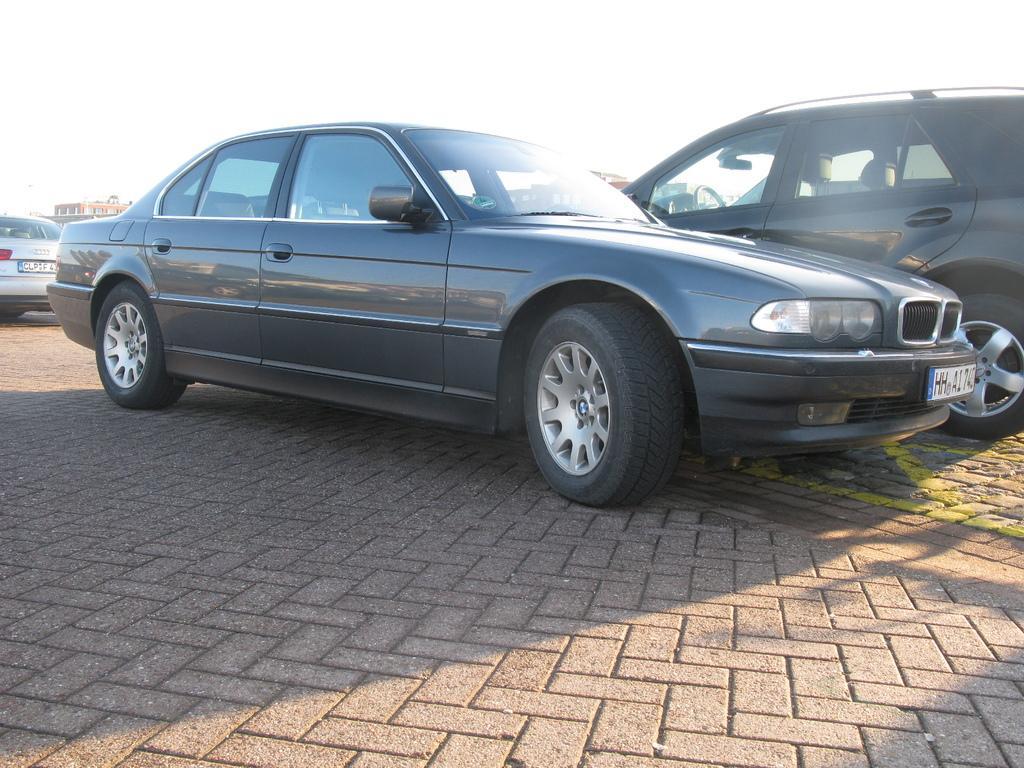Could you give a brief overview of what you see in this image? In this picture we can see few cars, in the background we can find few buildings. 